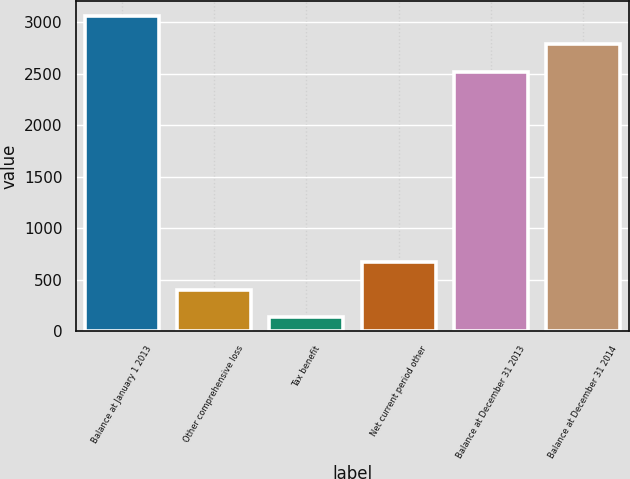<chart> <loc_0><loc_0><loc_500><loc_500><bar_chart><fcel>Balance at January 1 2013<fcel>Other comprehensive loss<fcel>Tax benefit<fcel>Net current period other<fcel>Balance at December 31 2013<fcel>Balance at December 31 2014<nl><fcel>3057.8<fcel>403.9<fcel>136<fcel>671.8<fcel>2522<fcel>2789.9<nl></chart> 